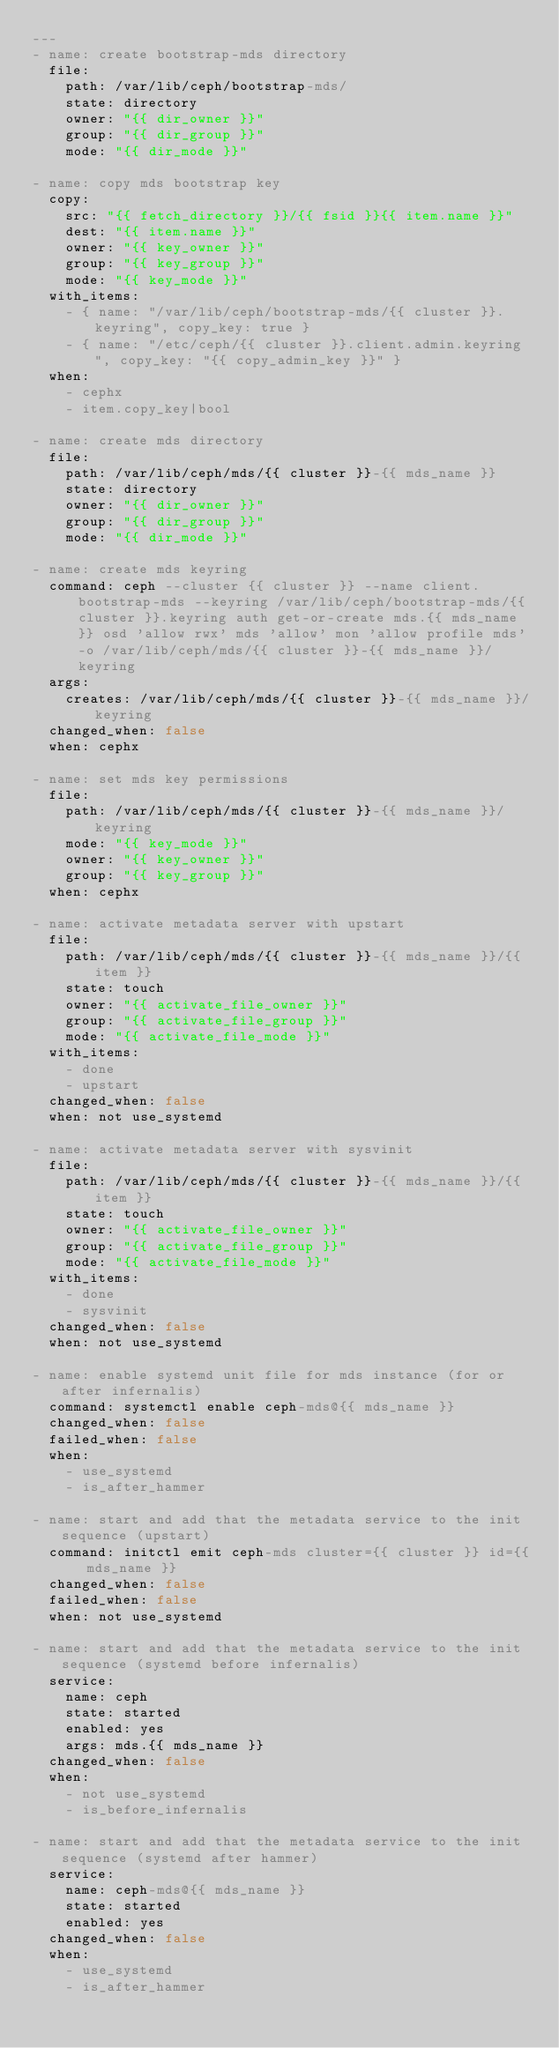<code> <loc_0><loc_0><loc_500><loc_500><_YAML_>---
- name: create bootstrap-mds directory
  file:
    path: /var/lib/ceph/bootstrap-mds/
    state: directory
    owner: "{{ dir_owner }}"
    group: "{{ dir_group }}"
    mode: "{{ dir_mode }}"

- name: copy mds bootstrap key
  copy:
    src: "{{ fetch_directory }}/{{ fsid }}{{ item.name }}"
    dest: "{{ item.name }}"
    owner: "{{ key_owner }}"
    group: "{{ key_group }}"
    mode: "{{ key_mode }}"
  with_items:
    - { name: "/var/lib/ceph/bootstrap-mds/{{ cluster }}.keyring", copy_key: true }
    - { name: "/etc/ceph/{{ cluster }}.client.admin.keyring", copy_key: "{{ copy_admin_key }}" }
  when:
    - cephx
    - item.copy_key|bool

- name: create mds directory
  file:
    path: /var/lib/ceph/mds/{{ cluster }}-{{ mds_name }}
    state: directory
    owner: "{{ dir_owner }}"
    group: "{{ dir_group }}"
    mode: "{{ dir_mode }}"

- name: create mds keyring
  command: ceph --cluster {{ cluster }} --name client.bootstrap-mds --keyring /var/lib/ceph/bootstrap-mds/{{ cluster }}.keyring auth get-or-create mds.{{ mds_name }} osd 'allow rwx' mds 'allow' mon 'allow profile mds' -o /var/lib/ceph/mds/{{ cluster }}-{{ mds_name }}/keyring
  args:
    creates: /var/lib/ceph/mds/{{ cluster }}-{{ mds_name }}/keyring
  changed_when: false
  when: cephx

- name: set mds key permissions
  file:
    path: /var/lib/ceph/mds/{{ cluster }}-{{ mds_name }}/keyring
    mode: "{{ key_mode }}"
    owner: "{{ key_owner }}"
    group: "{{ key_group }}"
  when: cephx

- name: activate metadata server with upstart
  file:
    path: /var/lib/ceph/mds/{{ cluster }}-{{ mds_name }}/{{ item }}
    state: touch
    owner: "{{ activate_file_owner }}"
    group: "{{ activate_file_group }}"
    mode: "{{ activate_file_mode }}"
  with_items:
    - done
    - upstart
  changed_when: false
  when: not use_systemd

- name: activate metadata server with sysvinit
  file:
    path: /var/lib/ceph/mds/{{ cluster }}-{{ mds_name }}/{{ item }}
    state: touch
    owner: "{{ activate_file_owner }}"
    group: "{{ activate_file_group }}"
    mode: "{{ activate_file_mode }}"
  with_items:
    - done
    - sysvinit
  changed_when: false
  when: not use_systemd

- name: enable systemd unit file for mds instance (for or after infernalis)
  command: systemctl enable ceph-mds@{{ mds_name }}
  changed_when: false
  failed_when: false
  when:
    - use_systemd
    - is_after_hammer

- name: start and add that the metadata service to the init sequence (upstart)
  command: initctl emit ceph-mds cluster={{ cluster }} id={{ mds_name }}
  changed_when: false
  failed_when: false
  when: not use_systemd

- name: start and add that the metadata service to the init sequence (systemd before infernalis)
  service:
    name: ceph
    state: started
    enabled: yes
    args: mds.{{ mds_name }}
  changed_when: false
  when:
    - not use_systemd
    - is_before_infernalis

- name: start and add that the metadata service to the init sequence (systemd after hammer)
  service:
    name: ceph-mds@{{ mds_name }}
    state: started
    enabled: yes
  changed_when: false
  when:
    - use_systemd
    - is_after_hammer
</code> 